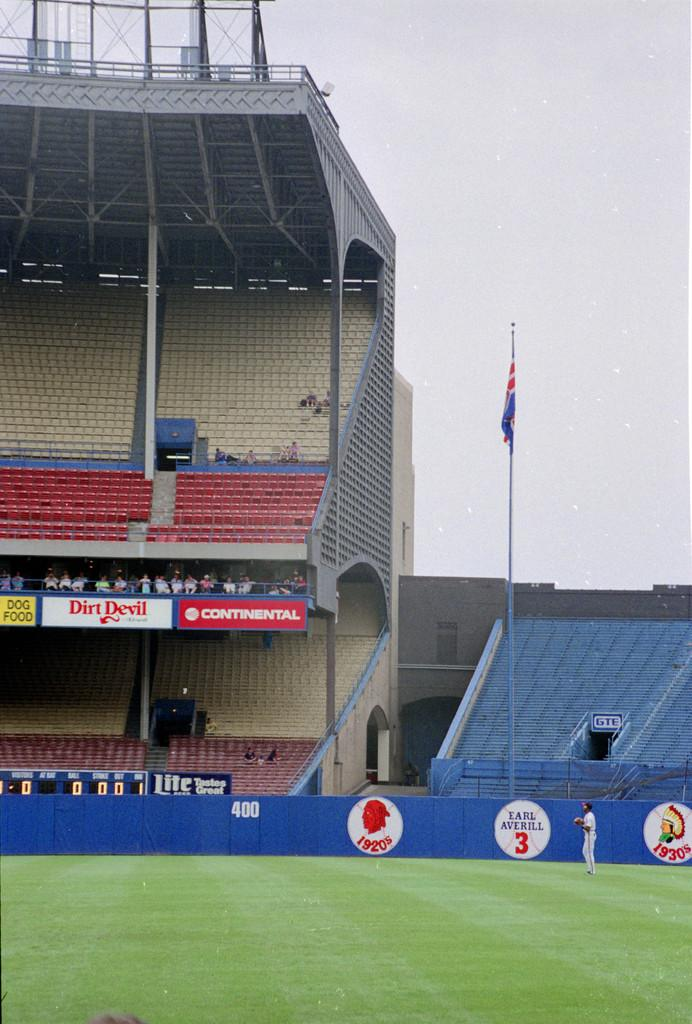<image>
Describe the image concisely. An outfielder stands in the grass near the Earl Averill tribute. 